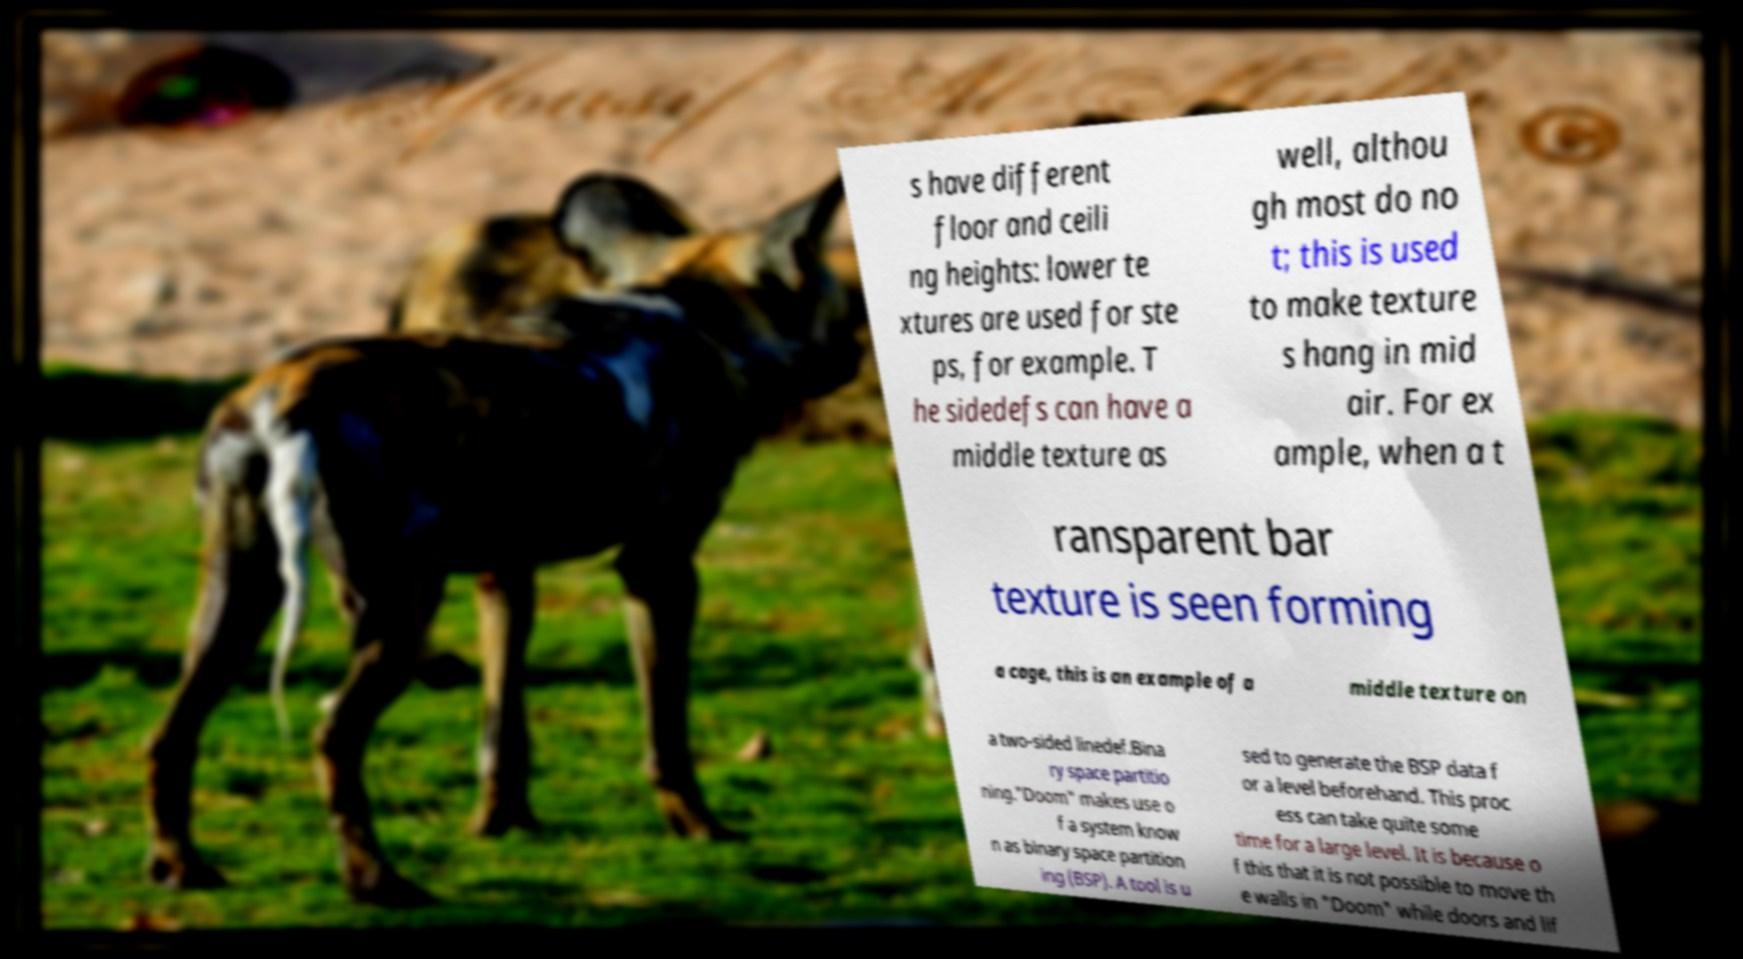There's text embedded in this image that I need extracted. Can you transcribe it verbatim? s have different floor and ceili ng heights: lower te xtures are used for ste ps, for example. T he sidedefs can have a middle texture as well, althou gh most do no t; this is used to make texture s hang in mid air. For ex ample, when a t ransparent bar texture is seen forming a cage, this is an example of a middle texture on a two-sided linedef.Bina ry space partitio ning."Doom" makes use o f a system know n as binary space partition ing (BSP). A tool is u sed to generate the BSP data f or a level beforehand. This proc ess can take quite some time for a large level. It is because o f this that it is not possible to move th e walls in "Doom" while doors and lif 